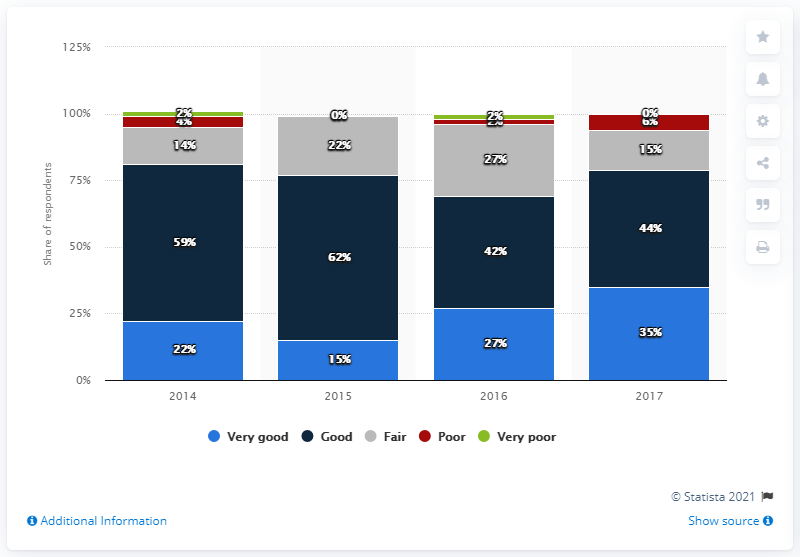Draw attention to some important aspects in this diagram. In 2017, 44% of students believed that the student housing subsector held promising investment prospects. 